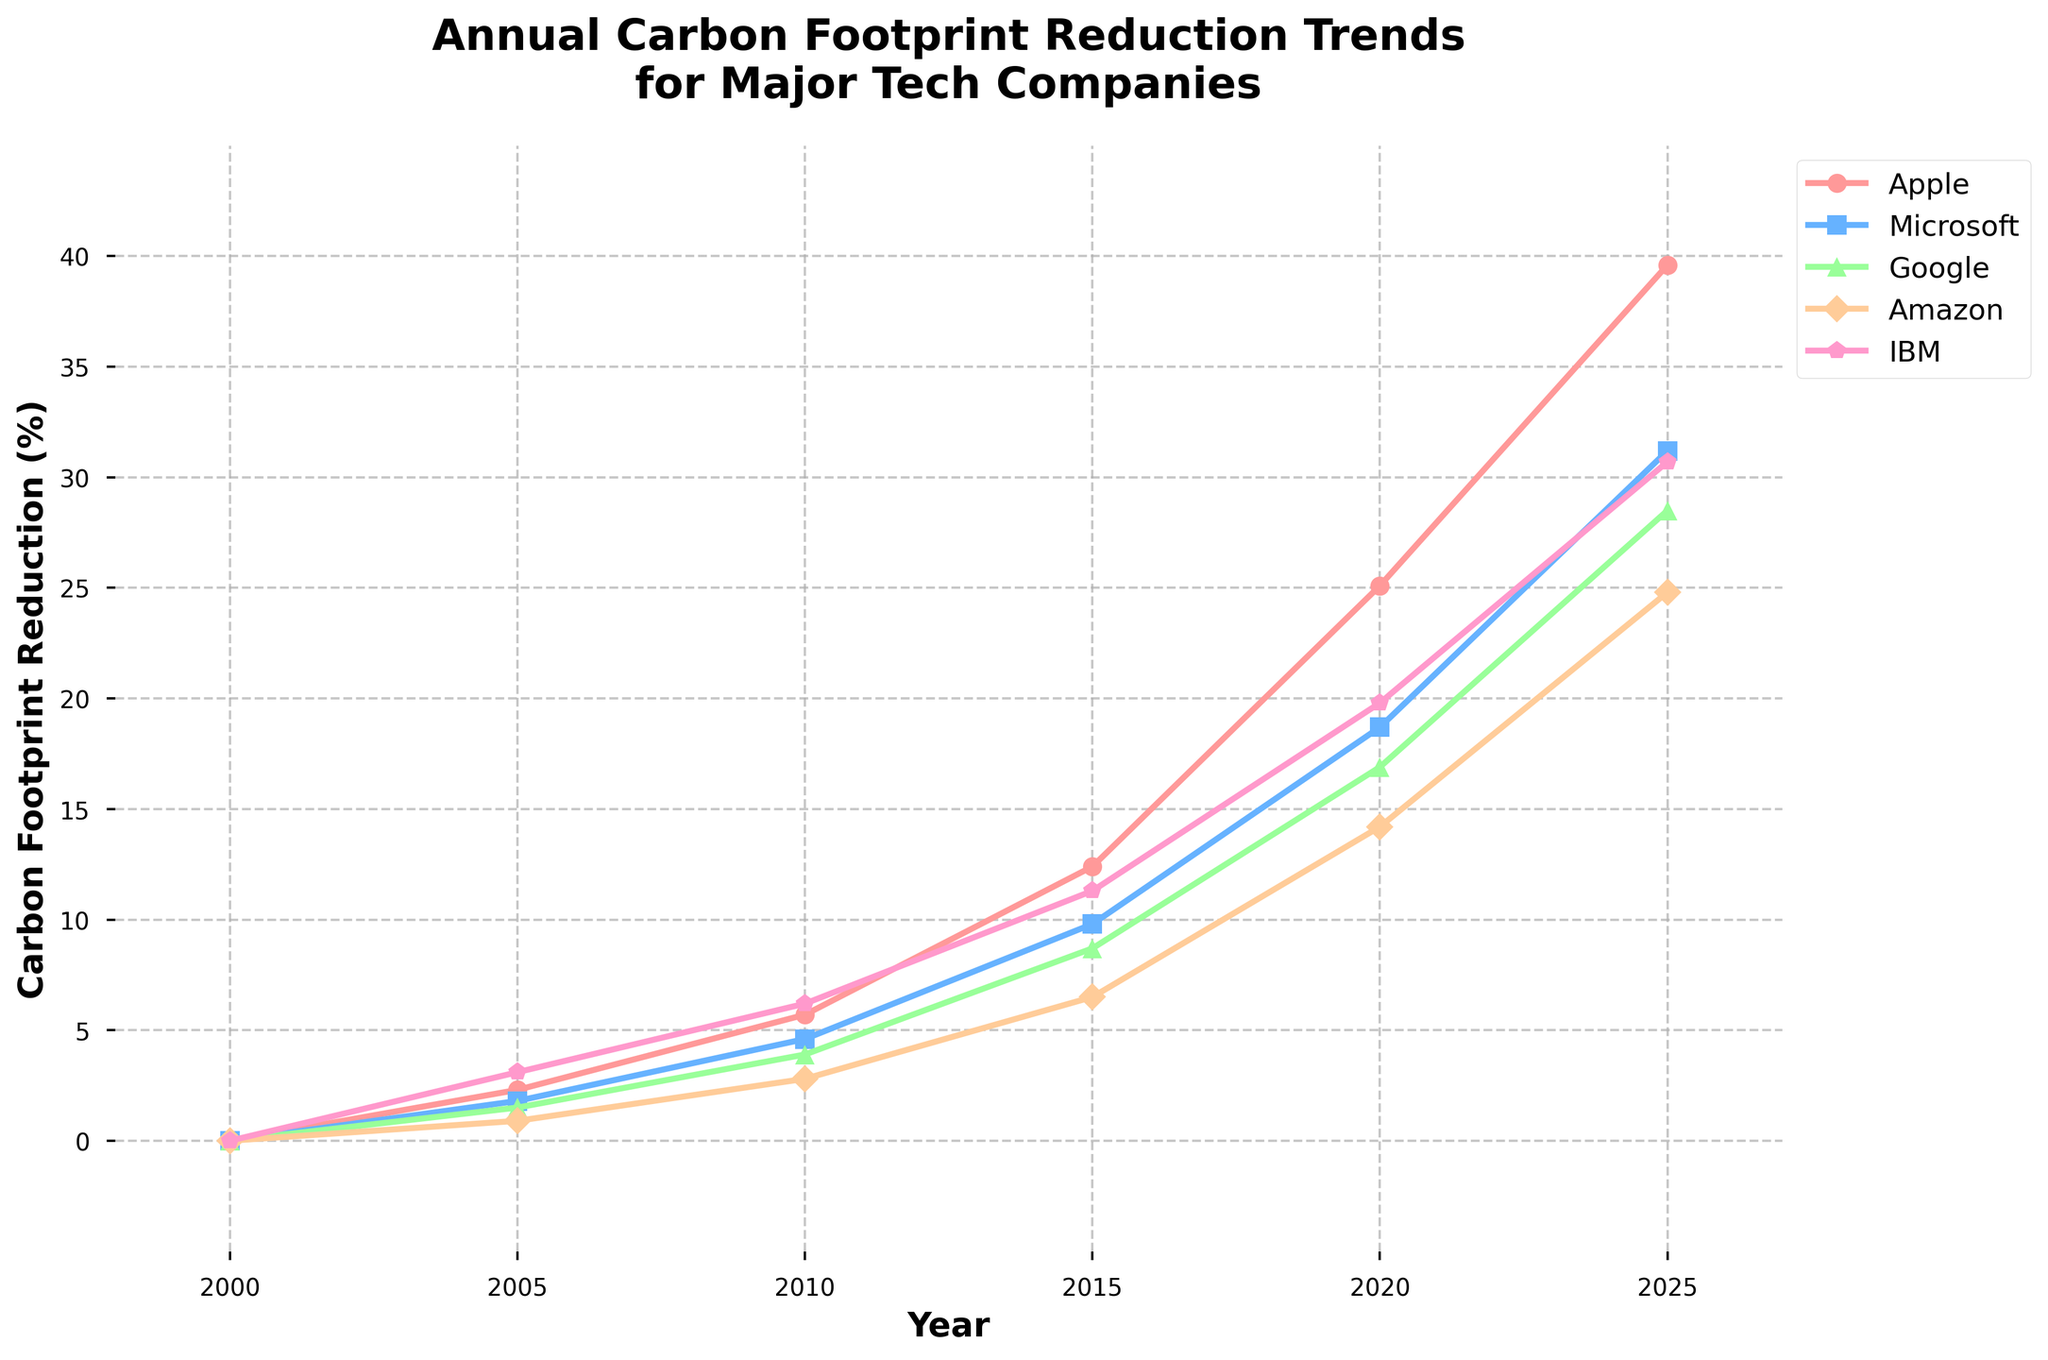Which company had the highest carbon footprint reduction in 2025? By looking at the rightmost point on the lines for each company in the year 2025, we see that Apple's line is the highest.
Answer: Apple Between 2010 and 2015, which company showed the largest increase in carbon footprint reduction? By calculating the difference between the 2015 and 2010 values for each company: Apple (12.4 - 5.7 = 6.7), Microsoft (9.8 - 4.6 = 5.2), Google (8.7 - 3.9 = 4.8), Amazon (6.5 - 2.8 = 3.7), IBM (11.3 - 6.2 = 5.1), the largest increase is by Apple.
Answer: Apple What is the difference in carbon footprint reduction between Microsoft and Google in 2020? By looking at the values for Microsoft (18.7) and Google (16.9) in the year 2020 and calculating the difference: 18.7 - 16.9 = 1.8.
Answer: 1.8 Which company's trend line is represented by a green marker? The Google trend line is represented by a green marker.
Answer: Google In which year did Amazon first surpass a 10% reduction in carbon footprint? Looking at the Amazon line, it surpasses the 10% mark between the years 2010 and 2015. Therefore, the year is 2015.
Answer: 2015 How many companies had a carbon footprint reduction greater than 15% in 2020? By checking the 2020 values, four companies (Apple, Microsoft, Google, and IBM) had reductions greater than 15%. Amazon had 14.2%, which is below 15%.
Answer: 4 Is IBM’s carbon footprint reduction more than double that of Amazon’s in the year 2015? IBM: 11.3, Amazon: 6.5. Checking if 11.3 is more than double 6.5: 6.5 * 2 = 13, and 11.3 is less than 13.
Answer: No What is the average carbon footprint reduction of all companies in 2005? Average = (Apple + Microsoft + Google + Amazon + IBM) / 5 = (2.3 + 1.8 + 1.5 + 0.9 + 3.1) / 5. The sum is 9.6, so the average is 9.6 / 5 = 1.92.
Answer: 1.92 